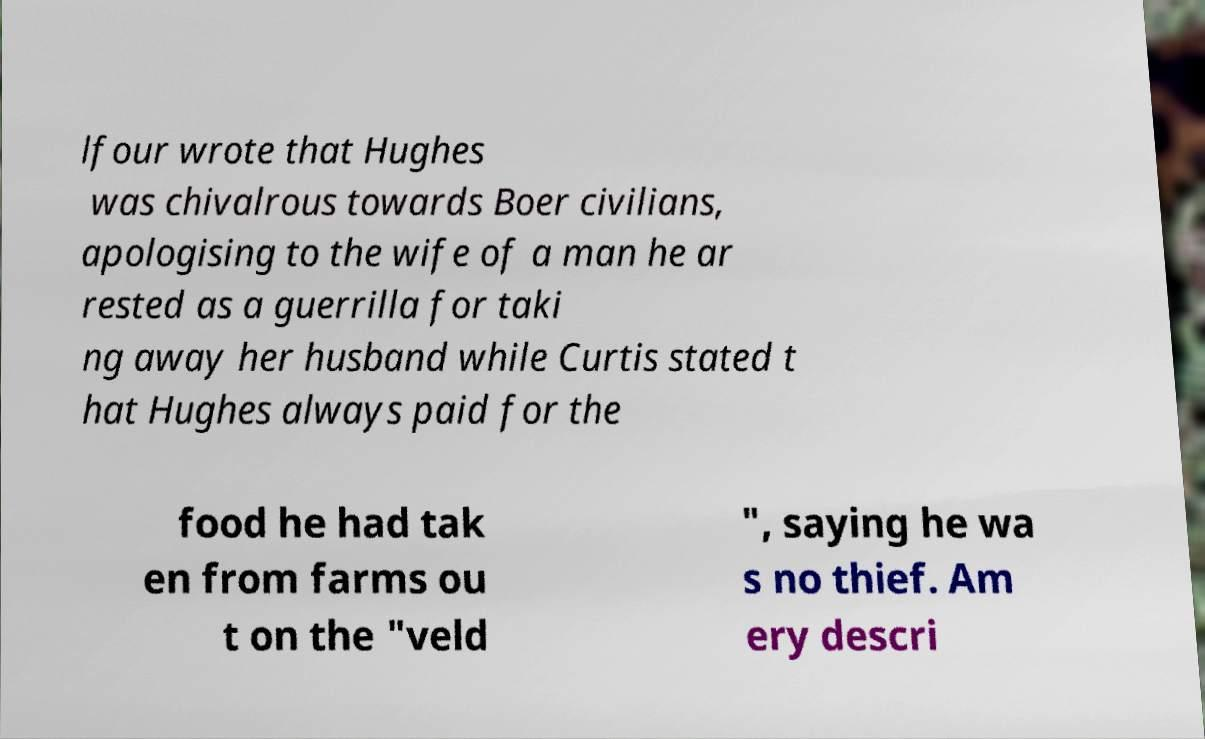Could you assist in decoding the text presented in this image and type it out clearly? lfour wrote that Hughes was chivalrous towards Boer civilians, apologising to the wife of a man he ar rested as a guerrilla for taki ng away her husband while Curtis stated t hat Hughes always paid for the food he had tak en from farms ou t on the "veld ", saying he wa s no thief. Am ery descri 